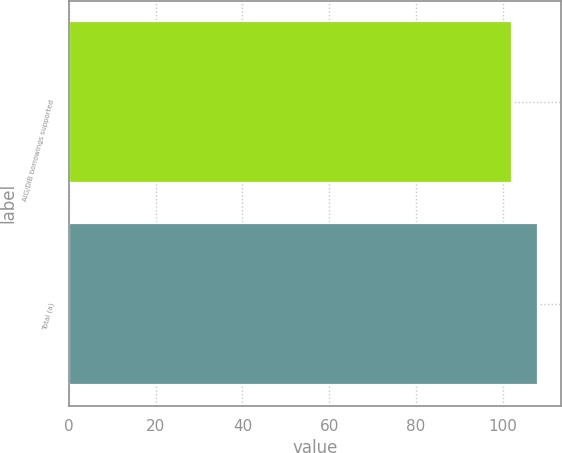Convert chart to OTSL. <chart><loc_0><loc_0><loc_500><loc_500><bar_chart><fcel>AIG/DIB borrowings supported<fcel>Total (a)<nl><fcel>102<fcel>108<nl></chart> 